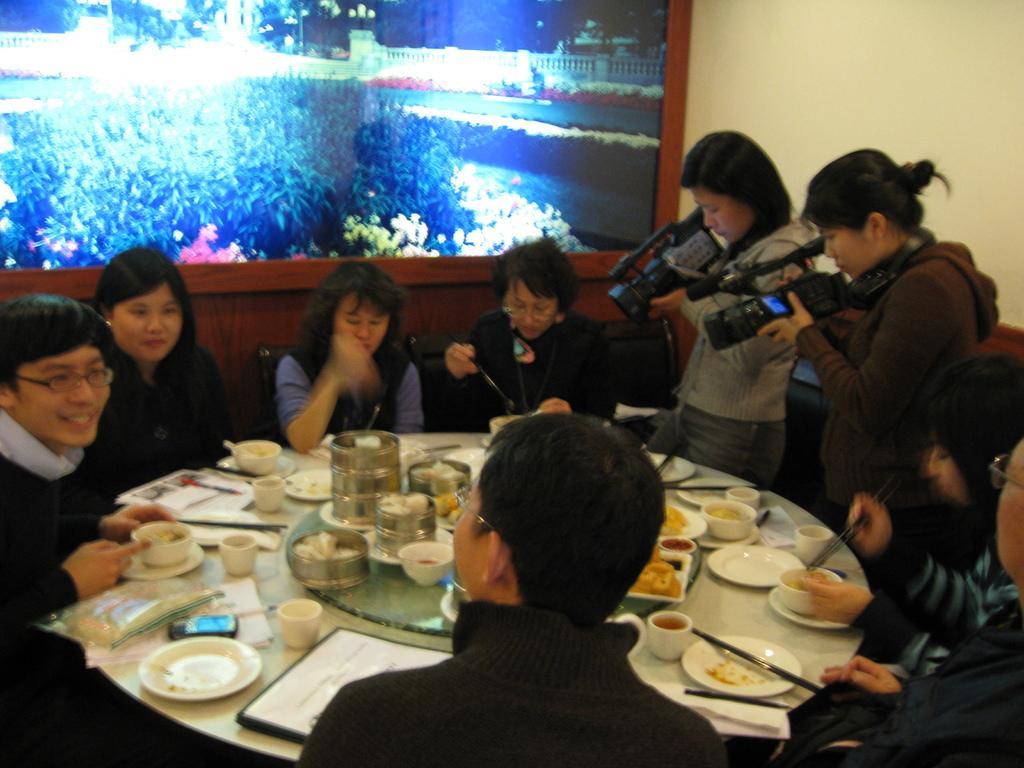How would you summarize this image in a sentence or two? In this picture we can see group of people, few are sitting and few are standing, in front of them we can find few plates, cups, bowls, chopsticks, food and other things on the table, in the background we can see a frame on the wall. 